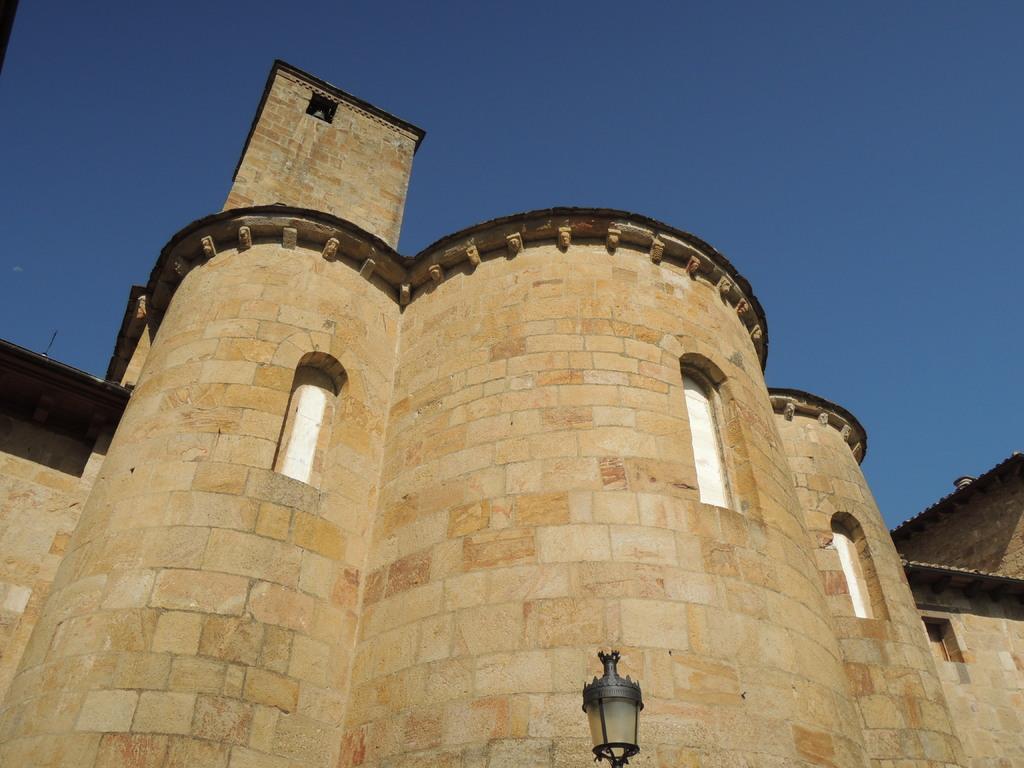How would you summarize this image in a sentence or two? In the center of the image there is a castle. At the bottom there is a light. In the background there is sky. 